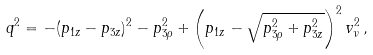Convert formula to latex. <formula><loc_0><loc_0><loc_500><loc_500>q ^ { 2 } = - ( p _ { 1 z } - p _ { 3 z } ) ^ { 2 } - p _ { 3 \rho } ^ { 2 } + \left ( p _ { 1 z } - \sqrt { p _ { 3 \rho } ^ { 2 } + p _ { 3 z } ^ { 2 } } \right ) ^ { 2 } v _ { \nu } ^ { 2 } \, ,</formula> 